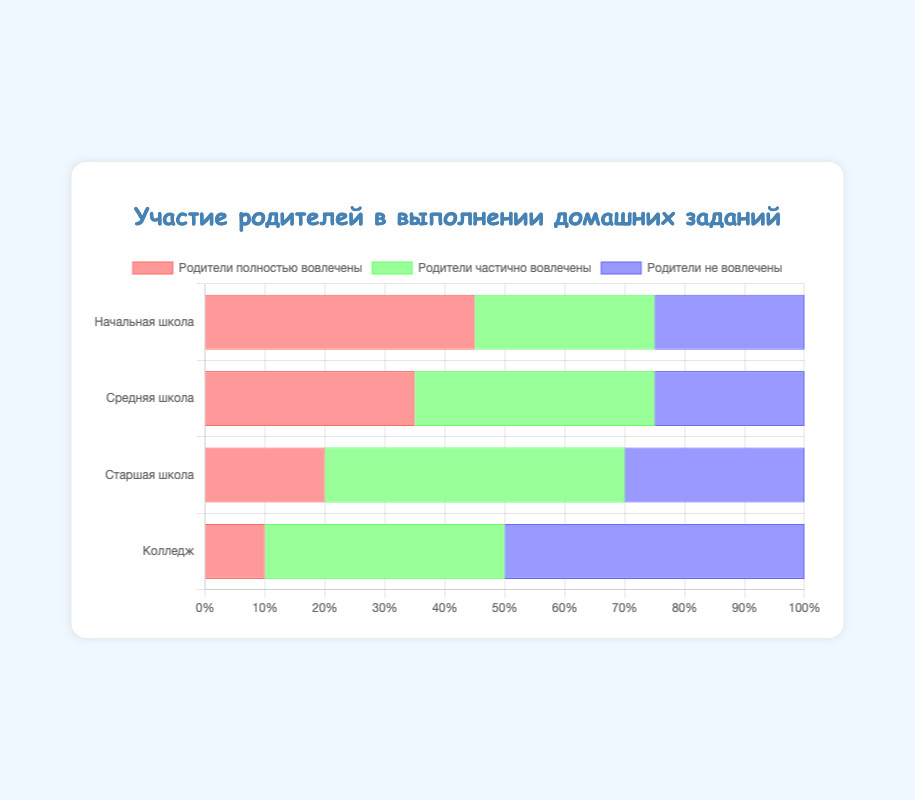Which education level has the highest percentage of fully involved parents? Look at the "Parents Fully Involved" category and compare the values for each education level. Primary School has 45, Middle School has 35, High School has 20, and College has 10.
Answer: Primary School Which education level has the highest number of parents not involved? Compare the "Parents Not Involved" category across each education level. Primary School has 25, Middle School has 25, High School has 30, and College has 50.
Answer: College What is the total involvement (fully + partially) of parents in Middle School? Add the numbers for "Parents Fully Involved" and "Parents Partially Involved" in Middle School. That’s 35 + 40 = 75.
Answer: 75 Compare the involvement (fully, partially, not involved) among education levels. Which category shows the greatest variation in numbers? Look across each involvement category for different education levels. "Parents Partially Involved" ranges from 30 to 50, varying the most.
Answer: Parents Partially Involved Which bar is the longest? By visual inspection, the "Parents Fully Involved" bar for Primary School appears longest.
Answer: Parents Fully Involved for Primary School For which education level are parents most likely to be only partially involved? Look for the highest value in the "Parents Partially Involved" category. High School has 50 partially involved parents, the highest among the levels.
Answer: High School What is the total percentage of parents not involved across all education levels combined? Sum the percentages for "Parents Not Involved": 25 (Primary) + 25 (Middle) + 30 (High) + 50 (College) = 130%.
Answer: 130 Comparing Primary School and College, which has more involvement (fully or partially) from parents? Primary School has 45 + 30 = 75; College has 10 + 40 = 50. Primary School has higher parental involvement.
Answer: Primary School How many more parents are fully involved in Primary School than in High School? Subtract the number of "Parents Fully Involved" in High School from that in Primary School. 45 - 20 = 25.
Answer: 25 By how much does the number of parents not involved increase from Middle School to College? Subtract the number of "Parents Not Involved" in Middle School from that in College. 50 - 25 = 25.
Answer: 25 